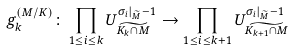<formula> <loc_0><loc_0><loc_500><loc_500>g _ { k } ^ { ( M / K ) } \colon \prod _ { 1 \leq i \leq k } U _ { \widetilde { K _ { k } \cap M } } ^ { \sigma _ { i } | _ { \widetilde { M } } - 1 } \rightarrow \prod _ { 1 \leq i \leq k + 1 } U _ { \widetilde { K _ { k + 1 } \cap M } } ^ { \sigma _ { i } | _ { \widetilde { M } } - 1 }</formula> 